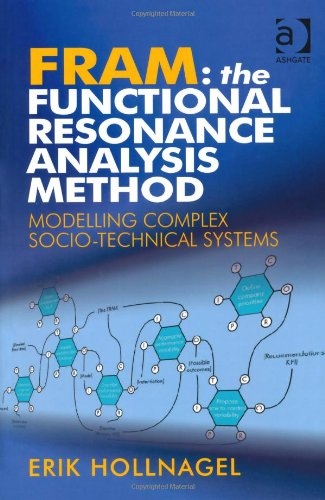Who is the author of this book? The author of 'FRAM: The Functional Resonance Analysis Method' is Erik Hollnagel, a renowned expert in the field of human reliability assessment and safety management. 